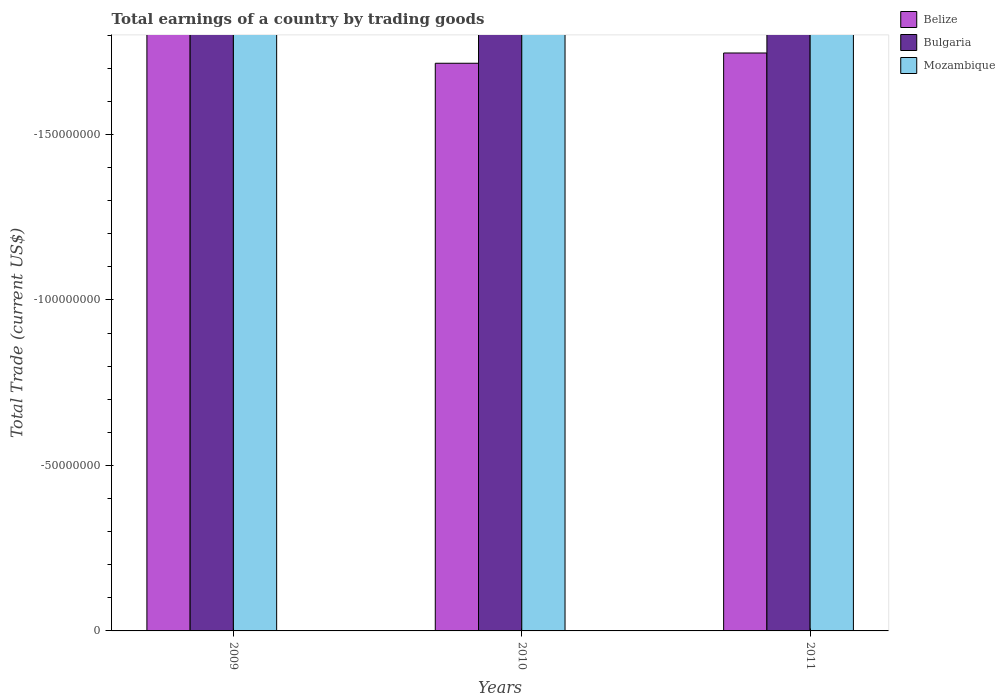How many different coloured bars are there?
Offer a terse response. 0. Are the number of bars per tick equal to the number of legend labels?
Provide a succinct answer. No. How many bars are there on the 3rd tick from the left?
Your response must be concise. 0. How many bars are there on the 3rd tick from the right?
Give a very brief answer. 0. In how many cases, is the number of bars for a given year not equal to the number of legend labels?
Your response must be concise. 3. What is the total earnings in Bulgaria in 2009?
Make the answer very short. 0. Across all years, what is the minimum total earnings in Bulgaria?
Your response must be concise. 0. What is the difference between the total earnings in Mozambique in 2010 and the total earnings in Belize in 2009?
Provide a succinct answer. 0. Is it the case that in every year, the sum of the total earnings in Bulgaria and total earnings in Belize is greater than the total earnings in Mozambique?
Provide a succinct answer. No. How many bars are there?
Offer a terse response. 0. How many years are there in the graph?
Provide a succinct answer. 3. What is the difference between two consecutive major ticks on the Y-axis?
Offer a very short reply. 5.00e+07. What is the title of the graph?
Give a very brief answer. Total earnings of a country by trading goods. What is the label or title of the Y-axis?
Give a very brief answer. Total Trade (current US$). What is the Total Trade (current US$) in Belize in 2009?
Keep it short and to the point. 0. What is the Total Trade (current US$) in Mozambique in 2010?
Your answer should be compact. 0. What is the Total Trade (current US$) of Belize in 2011?
Your answer should be very brief. 0. What is the Total Trade (current US$) in Bulgaria in 2011?
Offer a very short reply. 0. What is the total Total Trade (current US$) in Belize in the graph?
Your answer should be compact. 0. What is the total Total Trade (current US$) of Mozambique in the graph?
Make the answer very short. 0. What is the average Total Trade (current US$) of Belize per year?
Provide a succinct answer. 0. What is the average Total Trade (current US$) in Bulgaria per year?
Your answer should be compact. 0. What is the average Total Trade (current US$) of Mozambique per year?
Your answer should be very brief. 0. 